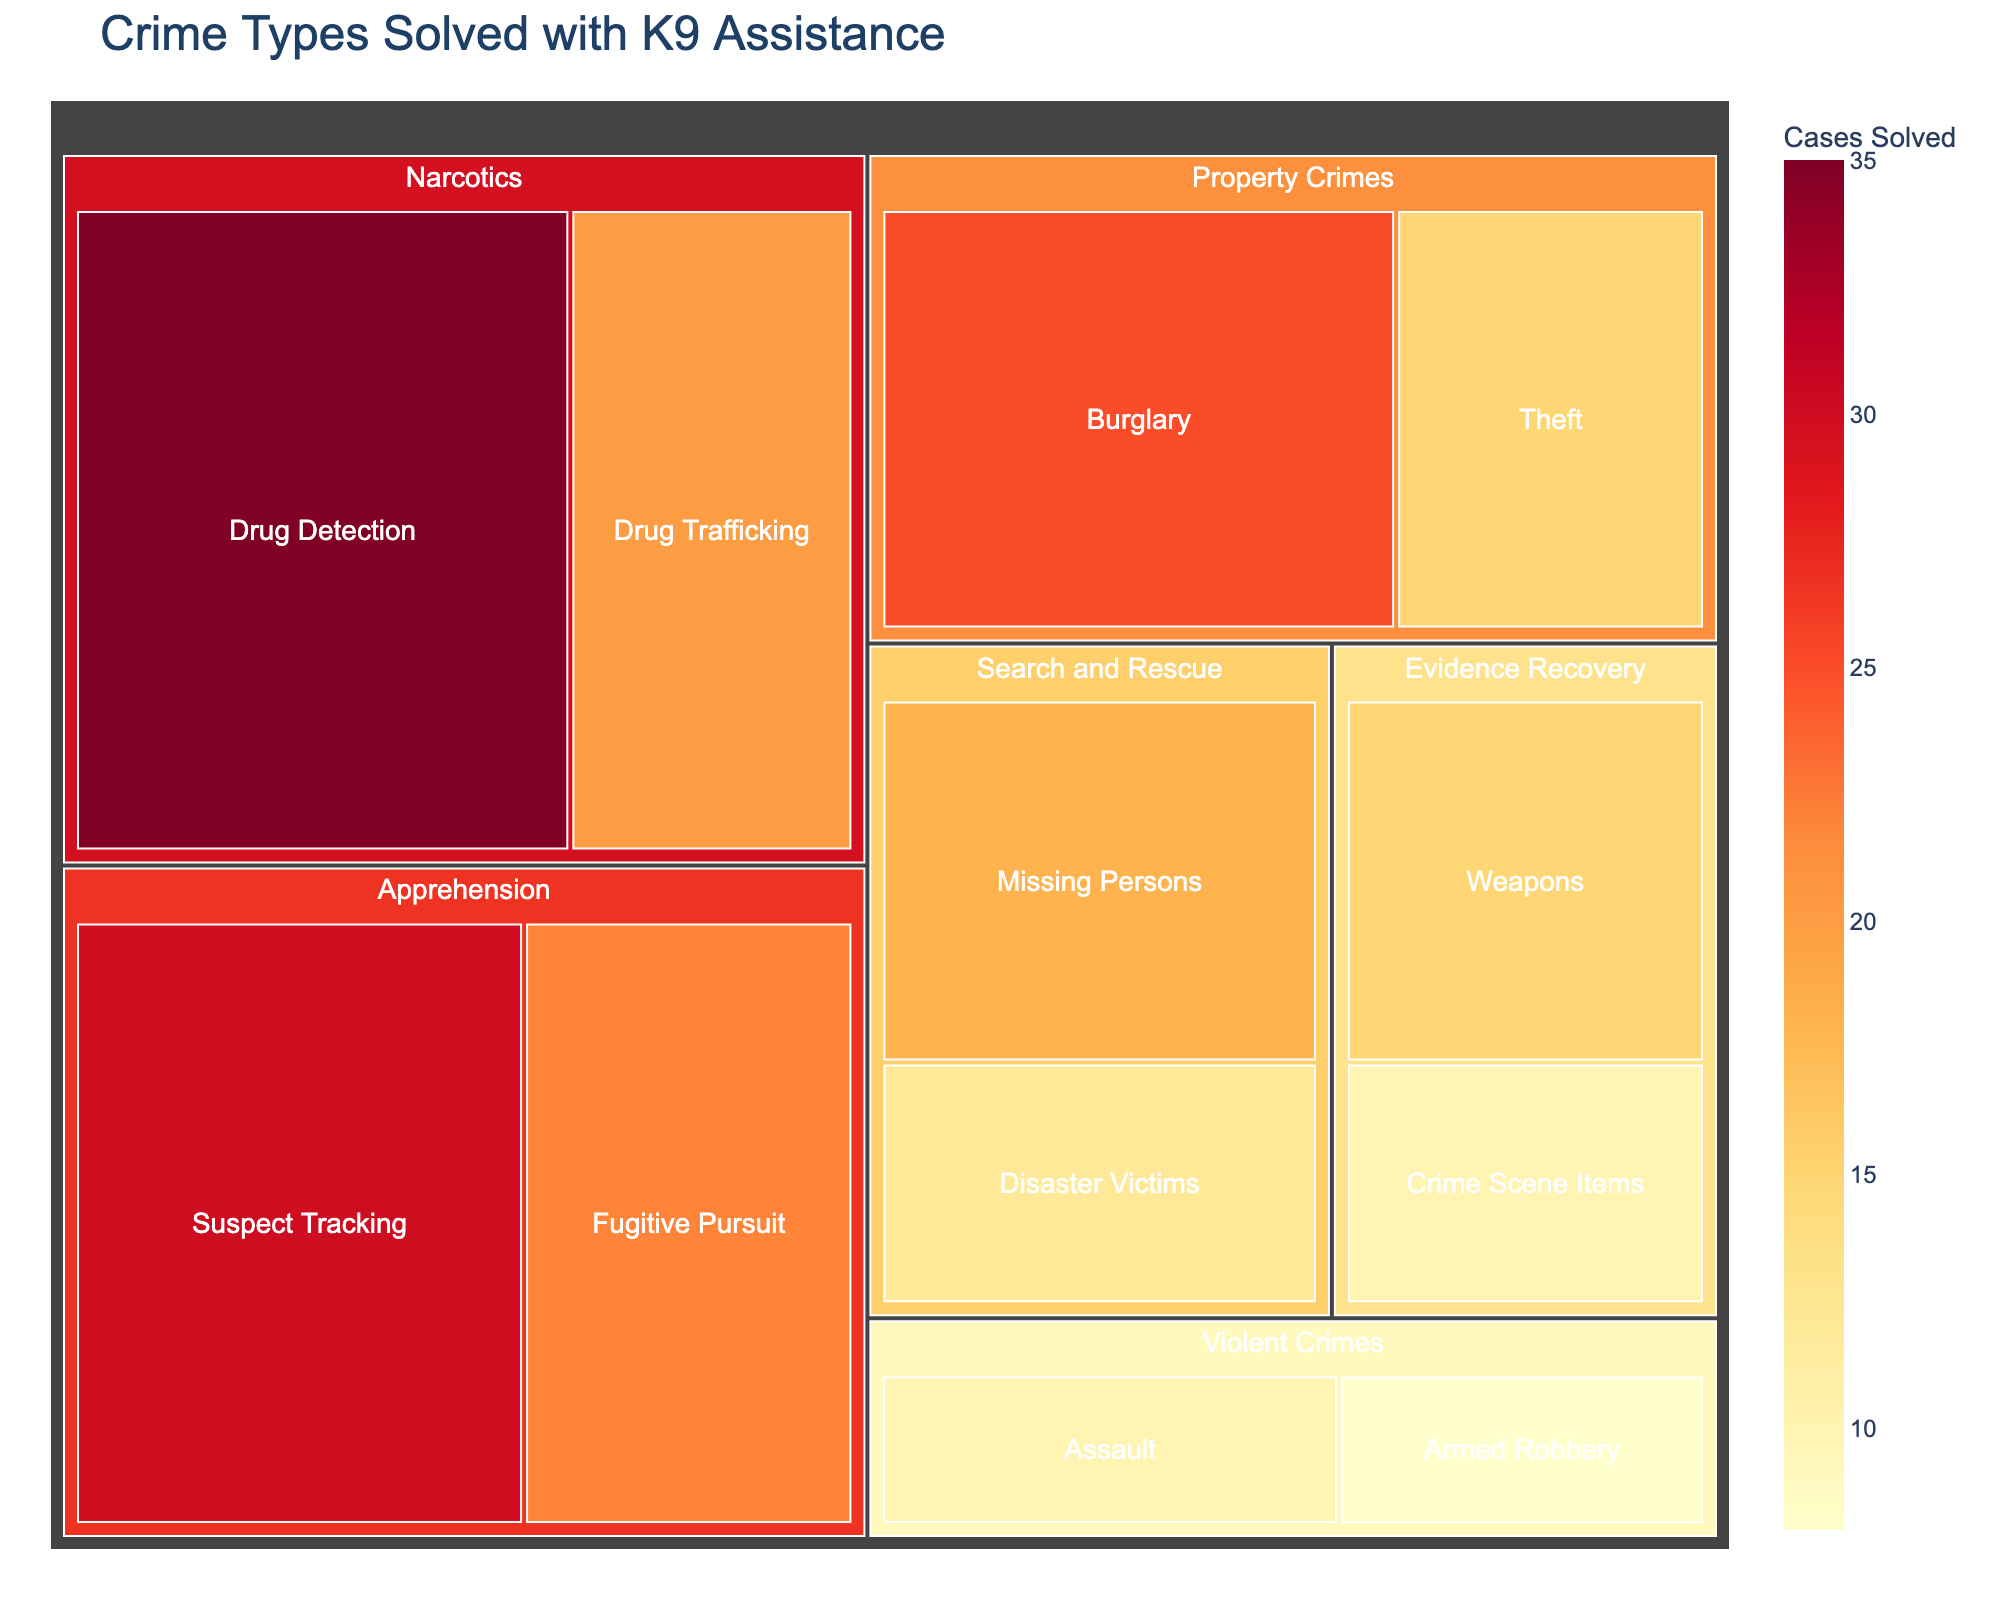What's the title of the treemap? Look at the top part of the figure where the title is usually placed. It reads "Crime Types Solved with K9 Assistance".
Answer: Crime Types Solved with K9 Assistance Which crime category has the highest number of cases solved with K9 assistance? To determine this, compare the total values across the main categories. The category with the largest sum is Narcotics (35 + 20 = 55).
Answer: Narcotics How many subcategories are there under Property Crimes? Check the subdivisions under the Property Crimes section. There are two subcategories: Burglary and Theft.
Answer: Two What is the total number of cases solved in the Apprehension category? Sum the values of the subcategories under the Apprehension category: Suspect Tracking (30) + Fugitive Pursuit (22) = 52.
Answer: 52 Which subcategory in the Evidence Recovery category has the lowest number of cases solved? Compare the values of the subcategories under Evidence Recovery. Crime Scene Items has 10 cases solved, which is lower than Weapons (15).
Answer: Crime Scene Items Which category has more cases solved: Violent Crimes or Search and Rescue? Sum the values of the subcategories for each category. Violent Crimes: Assault (10) + Armed Robbery (8) = 18. Search and Rescue: Missing Persons (18) + Disaster Victims (12) = 30. Since 30 is greater than 18, Search and Rescue has more cases solved.
Answer: Search and Rescue How many total cases have been solved with K9 units' assistance in the Evidence Recovery category? Sum the cases in the subcategories under Evidence Recovery: Weapons (15) + Crime Scene Items (10) = 25.
Answer: 25 Which subcategory has the highest value in the Narcotics category? Compare the values of the subcategories under Narcotics. Drug Detection has 35 cases, which is higher than Drug Trafficking (20).
Answer: Drug Detection Among the categories, which one has the smallest total number of cases solved with K9 assistance? Calculate the total for each category and compare them. Violent Crimes has the smallest total, with 18 cases (10 for Assault and 8 for Armed Robbery).
Answer: Violent Crimes 